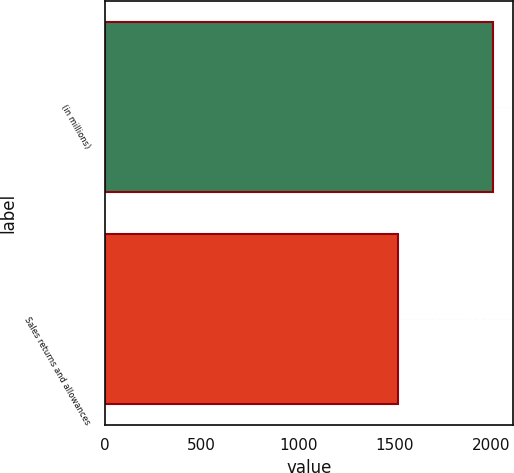Convert chart. <chart><loc_0><loc_0><loc_500><loc_500><bar_chart><fcel>(in millions)<fcel>Sales returns and allowances<nl><fcel>2010<fcel>1516.2<nl></chart> 